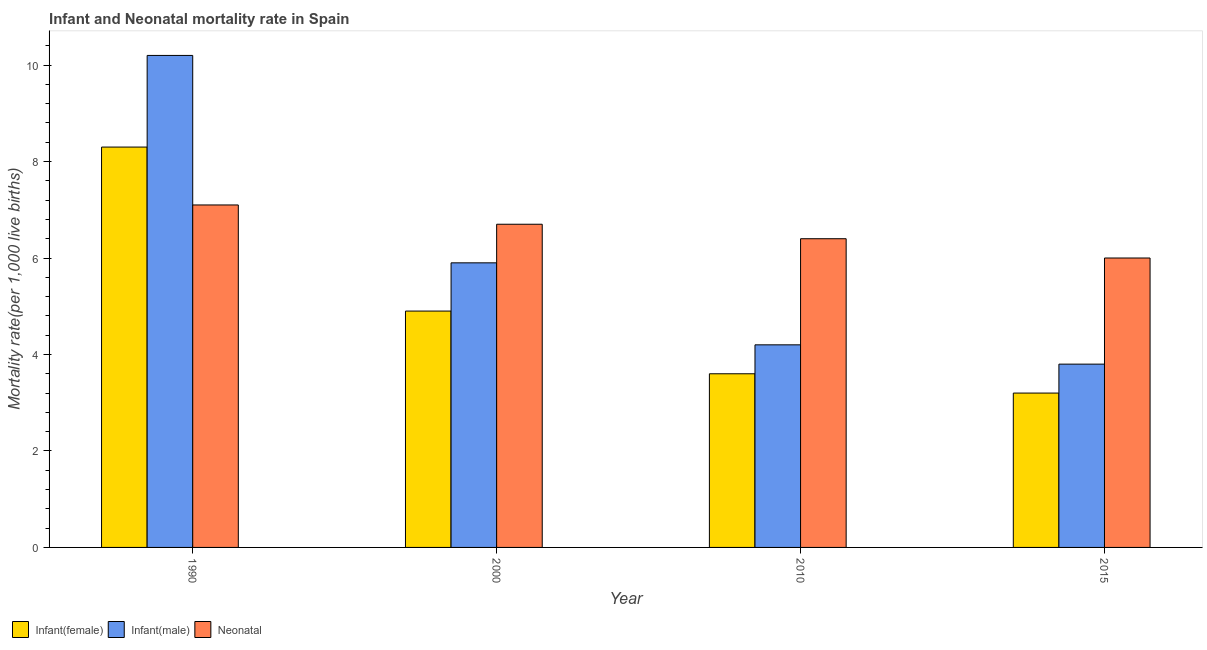Are the number of bars on each tick of the X-axis equal?
Give a very brief answer. Yes. How many bars are there on the 1st tick from the left?
Provide a short and direct response. 3. How many bars are there on the 1st tick from the right?
Make the answer very short. 3. In how many cases, is the number of bars for a given year not equal to the number of legend labels?
Give a very brief answer. 0. What is the infant mortality rate(female) in 1990?
Offer a terse response. 8.3. Across all years, what is the maximum infant mortality rate(female)?
Offer a terse response. 8.3. In which year was the neonatal mortality rate maximum?
Your answer should be compact. 1990. In which year was the neonatal mortality rate minimum?
Make the answer very short. 2015. What is the difference between the infant mortality rate(male) in 2010 and that in 2015?
Keep it short and to the point. 0.4. What is the difference between the infant mortality rate(female) in 2010 and the infant mortality rate(male) in 2015?
Your answer should be very brief. 0.4. What is the average infant mortality rate(female) per year?
Your answer should be compact. 5. In the year 2015, what is the difference between the neonatal mortality rate and infant mortality rate(male)?
Your response must be concise. 0. Is the difference between the infant mortality rate(female) in 2000 and 2015 greater than the difference between the neonatal mortality rate in 2000 and 2015?
Offer a very short reply. No. What is the difference between the highest and the second highest infant mortality rate(male)?
Your answer should be compact. 4.3. What is the difference between the highest and the lowest neonatal mortality rate?
Provide a succinct answer. 1.1. What does the 1st bar from the left in 1990 represents?
Your answer should be compact. Infant(female). What does the 1st bar from the right in 2015 represents?
Ensure brevity in your answer.  Neonatal . Is it the case that in every year, the sum of the infant mortality rate(female) and infant mortality rate(male) is greater than the neonatal mortality rate?
Give a very brief answer. Yes. How many bars are there?
Make the answer very short. 12. How many years are there in the graph?
Make the answer very short. 4. What is the difference between two consecutive major ticks on the Y-axis?
Your answer should be compact. 2. Are the values on the major ticks of Y-axis written in scientific E-notation?
Your answer should be compact. No. Does the graph contain any zero values?
Offer a terse response. No. Does the graph contain grids?
Offer a terse response. No. How many legend labels are there?
Offer a very short reply. 3. How are the legend labels stacked?
Offer a very short reply. Horizontal. What is the title of the graph?
Your answer should be very brief. Infant and Neonatal mortality rate in Spain. What is the label or title of the Y-axis?
Your answer should be very brief. Mortality rate(per 1,0 live births). What is the Mortality rate(per 1,000 live births) of Infant(female) in 2000?
Your response must be concise. 4.9. What is the Mortality rate(per 1,000 live births) in Infant(male) in 2000?
Ensure brevity in your answer.  5.9. What is the Mortality rate(per 1,000 live births) in Neonatal  in 2000?
Provide a succinct answer. 6.7. What is the Mortality rate(per 1,000 live births) in Infant(female) in 2010?
Provide a short and direct response. 3.6. What is the Mortality rate(per 1,000 live births) of Infant(male) in 2010?
Give a very brief answer. 4.2. What is the Mortality rate(per 1,000 live births) of Neonatal  in 2010?
Offer a terse response. 6.4. Across all years, what is the maximum Mortality rate(per 1,000 live births) of Infant(female)?
Provide a succinct answer. 8.3. Across all years, what is the minimum Mortality rate(per 1,000 live births) in Infant(female)?
Offer a terse response. 3.2. Across all years, what is the minimum Mortality rate(per 1,000 live births) in Infant(male)?
Offer a very short reply. 3.8. What is the total Mortality rate(per 1,000 live births) of Infant(female) in the graph?
Your response must be concise. 20. What is the total Mortality rate(per 1,000 live births) of Infant(male) in the graph?
Give a very brief answer. 24.1. What is the total Mortality rate(per 1,000 live births) of Neonatal  in the graph?
Your answer should be very brief. 26.2. What is the difference between the Mortality rate(per 1,000 live births) of Infant(female) in 1990 and that in 2000?
Your answer should be very brief. 3.4. What is the difference between the Mortality rate(per 1,000 live births) of Infant(male) in 1990 and that in 2000?
Provide a succinct answer. 4.3. What is the difference between the Mortality rate(per 1,000 live births) in Infant(female) in 1990 and that in 2010?
Ensure brevity in your answer.  4.7. What is the difference between the Mortality rate(per 1,000 live births) in Infant(male) in 1990 and that in 2010?
Provide a succinct answer. 6. What is the difference between the Mortality rate(per 1,000 live births) in Infant(female) in 1990 and that in 2015?
Provide a succinct answer. 5.1. What is the difference between the Mortality rate(per 1,000 live births) in Infant(female) in 2000 and that in 2010?
Offer a very short reply. 1.3. What is the difference between the Mortality rate(per 1,000 live births) in Neonatal  in 2000 and that in 2010?
Your answer should be very brief. 0.3. What is the difference between the Mortality rate(per 1,000 live births) in Infant(female) in 2000 and that in 2015?
Ensure brevity in your answer.  1.7. What is the difference between the Mortality rate(per 1,000 live births) of Neonatal  in 2000 and that in 2015?
Provide a succinct answer. 0.7. What is the difference between the Mortality rate(per 1,000 live births) in Neonatal  in 2010 and that in 2015?
Provide a short and direct response. 0.4. What is the difference between the Mortality rate(per 1,000 live births) of Infant(female) in 1990 and the Mortality rate(per 1,000 live births) of Neonatal  in 2000?
Give a very brief answer. 1.6. What is the difference between the Mortality rate(per 1,000 live births) of Infant(female) in 1990 and the Mortality rate(per 1,000 live births) of Infant(male) in 2010?
Make the answer very short. 4.1. What is the difference between the Mortality rate(per 1,000 live births) in Infant(female) in 1990 and the Mortality rate(per 1,000 live births) in Neonatal  in 2010?
Provide a succinct answer. 1.9. What is the difference between the Mortality rate(per 1,000 live births) of Infant(male) in 1990 and the Mortality rate(per 1,000 live births) of Neonatal  in 2015?
Your answer should be very brief. 4.2. What is the difference between the Mortality rate(per 1,000 live births) in Infant(female) in 2000 and the Mortality rate(per 1,000 live births) in Infant(male) in 2015?
Provide a short and direct response. 1.1. What is the difference between the Mortality rate(per 1,000 live births) of Infant(male) in 2000 and the Mortality rate(per 1,000 live births) of Neonatal  in 2015?
Your answer should be compact. -0.1. What is the difference between the Mortality rate(per 1,000 live births) of Infant(female) in 2010 and the Mortality rate(per 1,000 live births) of Infant(male) in 2015?
Your answer should be very brief. -0.2. What is the average Mortality rate(per 1,000 live births) of Infant(female) per year?
Your response must be concise. 5. What is the average Mortality rate(per 1,000 live births) of Infant(male) per year?
Offer a very short reply. 6.03. What is the average Mortality rate(per 1,000 live births) in Neonatal  per year?
Your response must be concise. 6.55. In the year 1990, what is the difference between the Mortality rate(per 1,000 live births) in Infant(female) and Mortality rate(per 1,000 live births) in Infant(male)?
Offer a very short reply. -1.9. In the year 1990, what is the difference between the Mortality rate(per 1,000 live births) of Infant(female) and Mortality rate(per 1,000 live births) of Neonatal ?
Your answer should be very brief. 1.2. In the year 2000, what is the difference between the Mortality rate(per 1,000 live births) of Infant(female) and Mortality rate(per 1,000 live births) of Neonatal ?
Your answer should be compact. -1.8. In the year 2010, what is the difference between the Mortality rate(per 1,000 live births) of Infant(female) and Mortality rate(per 1,000 live births) of Infant(male)?
Make the answer very short. -0.6. In the year 2015, what is the difference between the Mortality rate(per 1,000 live births) in Infant(female) and Mortality rate(per 1,000 live births) in Infant(male)?
Provide a succinct answer. -0.6. In the year 2015, what is the difference between the Mortality rate(per 1,000 live births) of Infant(female) and Mortality rate(per 1,000 live births) of Neonatal ?
Your answer should be compact. -2.8. What is the ratio of the Mortality rate(per 1,000 live births) of Infant(female) in 1990 to that in 2000?
Your answer should be very brief. 1.69. What is the ratio of the Mortality rate(per 1,000 live births) of Infant(male) in 1990 to that in 2000?
Offer a terse response. 1.73. What is the ratio of the Mortality rate(per 1,000 live births) in Neonatal  in 1990 to that in 2000?
Give a very brief answer. 1.06. What is the ratio of the Mortality rate(per 1,000 live births) of Infant(female) in 1990 to that in 2010?
Ensure brevity in your answer.  2.31. What is the ratio of the Mortality rate(per 1,000 live births) in Infant(male) in 1990 to that in 2010?
Provide a succinct answer. 2.43. What is the ratio of the Mortality rate(per 1,000 live births) of Neonatal  in 1990 to that in 2010?
Your answer should be very brief. 1.11. What is the ratio of the Mortality rate(per 1,000 live births) of Infant(female) in 1990 to that in 2015?
Provide a short and direct response. 2.59. What is the ratio of the Mortality rate(per 1,000 live births) of Infant(male) in 1990 to that in 2015?
Make the answer very short. 2.68. What is the ratio of the Mortality rate(per 1,000 live births) in Neonatal  in 1990 to that in 2015?
Offer a very short reply. 1.18. What is the ratio of the Mortality rate(per 1,000 live births) of Infant(female) in 2000 to that in 2010?
Your answer should be very brief. 1.36. What is the ratio of the Mortality rate(per 1,000 live births) of Infant(male) in 2000 to that in 2010?
Offer a terse response. 1.4. What is the ratio of the Mortality rate(per 1,000 live births) of Neonatal  in 2000 to that in 2010?
Keep it short and to the point. 1.05. What is the ratio of the Mortality rate(per 1,000 live births) of Infant(female) in 2000 to that in 2015?
Offer a very short reply. 1.53. What is the ratio of the Mortality rate(per 1,000 live births) of Infant(male) in 2000 to that in 2015?
Your response must be concise. 1.55. What is the ratio of the Mortality rate(per 1,000 live births) in Neonatal  in 2000 to that in 2015?
Ensure brevity in your answer.  1.12. What is the ratio of the Mortality rate(per 1,000 live births) of Infant(male) in 2010 to that in 2015?
Make the answer very short. 1.11. What is the ratio of the Mortality rate(per 1,000 live births) of Neonatal  in 2010 to that in 2015?
Provide a short and direct response. 1.07. What is the difference between the highest and the second highest Mortality rate(per 1,000 live births) in Infant(female)?
Provide a short and direct response. 3.4. What is the difference between the highest and the second highest Mortality rate(per 1,000 live births) in Neonatal ?
Give a very brief answer. 0.4. What is the difference between the highest and the lowest Mortality rate(per 1,000 live births) in Infant(male)?
Give a very brief answer. 6.4. 